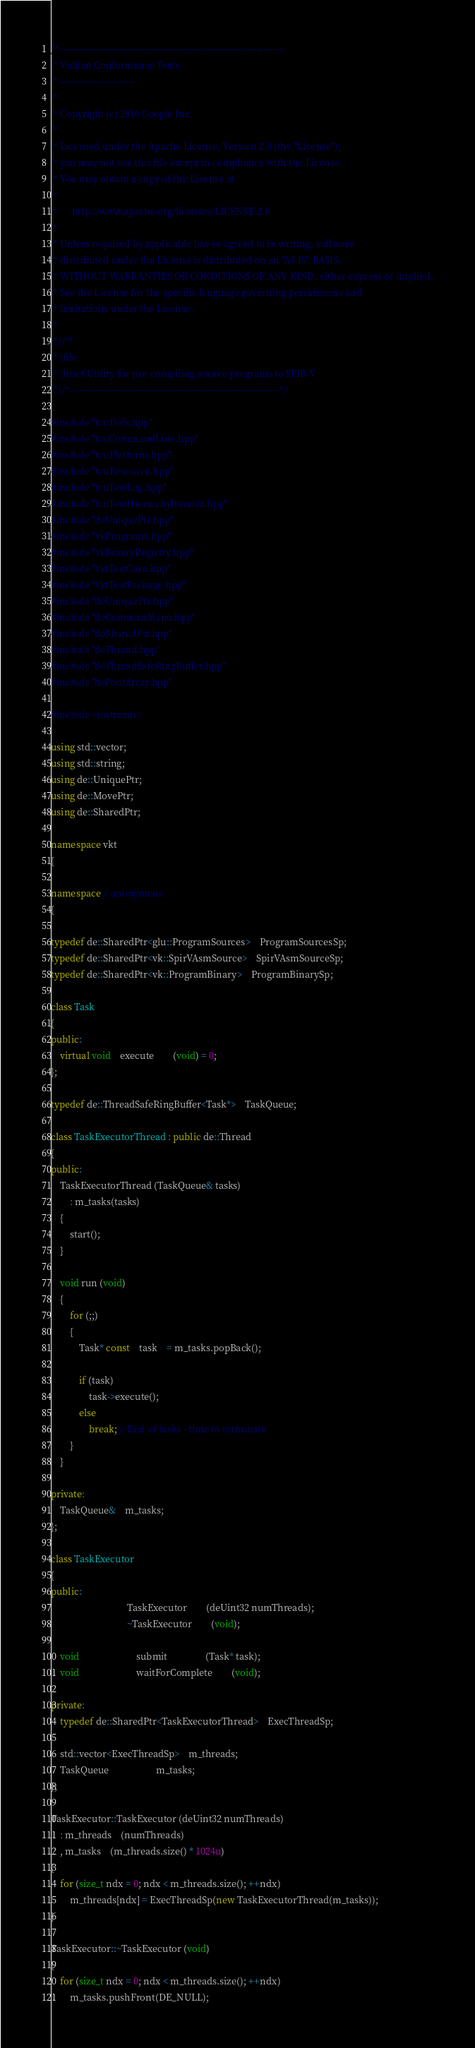<code> <loc_0><loc_0><loc_500><loc_500><_C++_>/*-------------------------------------------------------------------------
 * Vulkan Conformance Tests
 * ------------------------
 *
 * Copyright (c) 2016 Google Inc.
 *
 * Licensed under the Apache License, Version 2.0 (the "License");
 * you may not use this file except in compliance with the License.
 * You may obtain a copy of the License at
 *
 *      http://www.apache.org/licenses/LICENSE-2.0
 *
 * Unless required by applicable law or agreed to in writing, software
 * distributed under the License is distributed on an "AS IS" BASIS,
 * WITHOUT WARRANTIES OR CONDITIONS OF ANY KIND, either express or implied.
 * See the License for the specific language governing permissions and
 * limitations under the License.
 *
 *//*!
 * \file
 * \brief Utility for pre-compiling source programs to SPIR-V
 *//*--------------------------------------------------------------------*/

#include "tcuDefs.hpp"
#include "tcuCommandLine.hpp"
#include "tcuPlatform.hpp"
#include "tcuResource.hpp"
#include "tcuTestLog.hpp"
#include "tcuTestHierarchyIterator.hpp"
#include "deUniquePtr.hpp"
#include "vkPrograms.hpp"
#include "vkBinaryRegistry.hpp"
#include "vktTestCase.hpp"
#include "vktTestPackage.hpp"
#include "deUniquePtr.hpp"
#include "deCommandLine.hpp"
#include "deSharedPtr.hpp"
#include "deThread.hpp"
#include "deThreadSafeRingBuffer.hpp"
#include "dePoolArray.hpp"

#include <iostream>

using std::vector;
using std::string;
using de::UniquePtr;
using de::MovePtr;
using de::SharedPtr;

namespace vkt
{

namespace // anonymous
{

typedef de::SharedPtr<glu::ProgramSources>	ProgramSourcesSp;
typedef de::SharedPtr<vk::SpirVAsmSource>	SpirVAsmSourceSp;
typedef de::SharedPtr<vk::ProgramBinary>	ProgramBinarySp;

class Task
{
public:
	virtual void	execute		(void) = 0;
};

typedef de::ThreadSafeRingBuffer<Task*>	TaskQueue;

class TaskExecutorThread : public de::Thread
{
public:
	TaskExecutorThread (TaskQueue& tasks)
		: m_tasks(tasks)
	{
		start();
	}

	void run (void)
	{
		for (;;)
		{
			Task* const	task	= m_tasks.popBack();

			if (task)
				task->execute();
			else
				break; // End of tasks - time to terminate
		}
	}

private:
	TaskQueue&	m_tasks;
};

class TaskExecutor
{
public:
								TaskExecutor		(deUint32 numThreads);
								~TaskExecutor		(void);

	void						submit				(Task* task);
	void						waitForComplete		(void);

private:
	typedef de::SharedPtr<TaskExecutorThread>	ExecThreadSp;

	std::vector<ExecThreadSp>	m_threads;
	TaskQueue					m_tasks;
};

TaskExecutor::TaskExecutor (deUint32 numThreads)
	: m_threads	(numThreads)
	, m_tasks	(m_threads.size() * 1024u)
{
	for (size_t ndx = 0; ndx < m_threads.size(); ++ndx)
		m_threads[ndx] = ExecThreadSp(new TaskExecutorThread(m_tasks));
}

TaskExecutor::~TaskExecutor (void)
{
	for (size_t ndx = 0; ndx < m_threads.size(); ++ndx)
		m_tasks.pushFront(DE_NULL);
</code> 